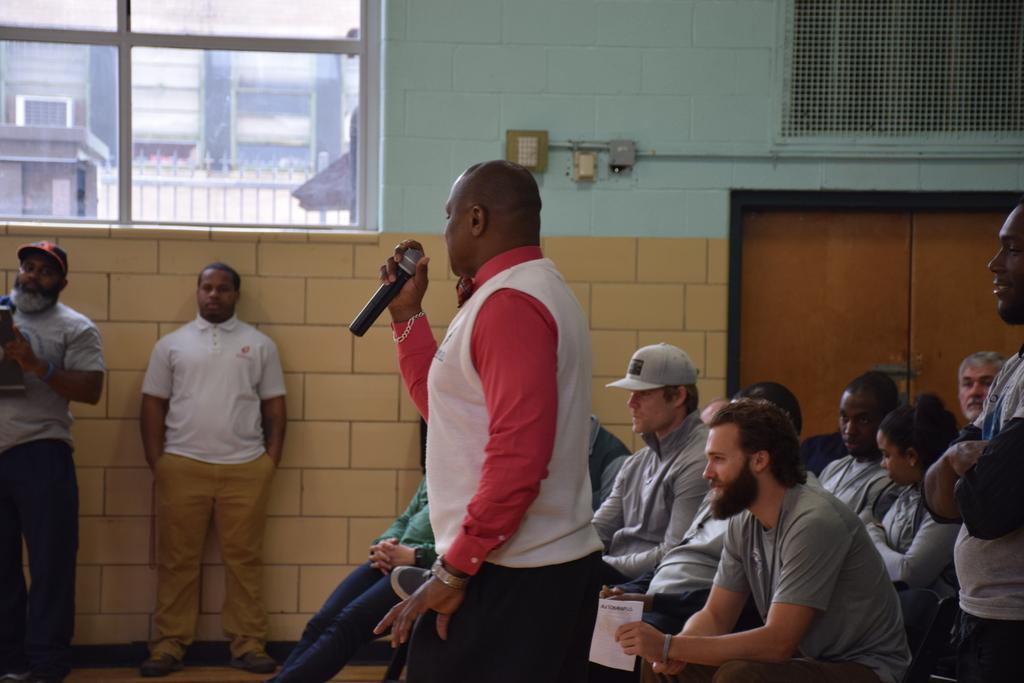In one or two sentences, can you explain what this image depicts? In this image we can see people sitting on the chairs and some are standing on the floor and one of them is holding a mic in the hands. In the background we can see buildings, grills, electric shafts, pipeline and a window. 